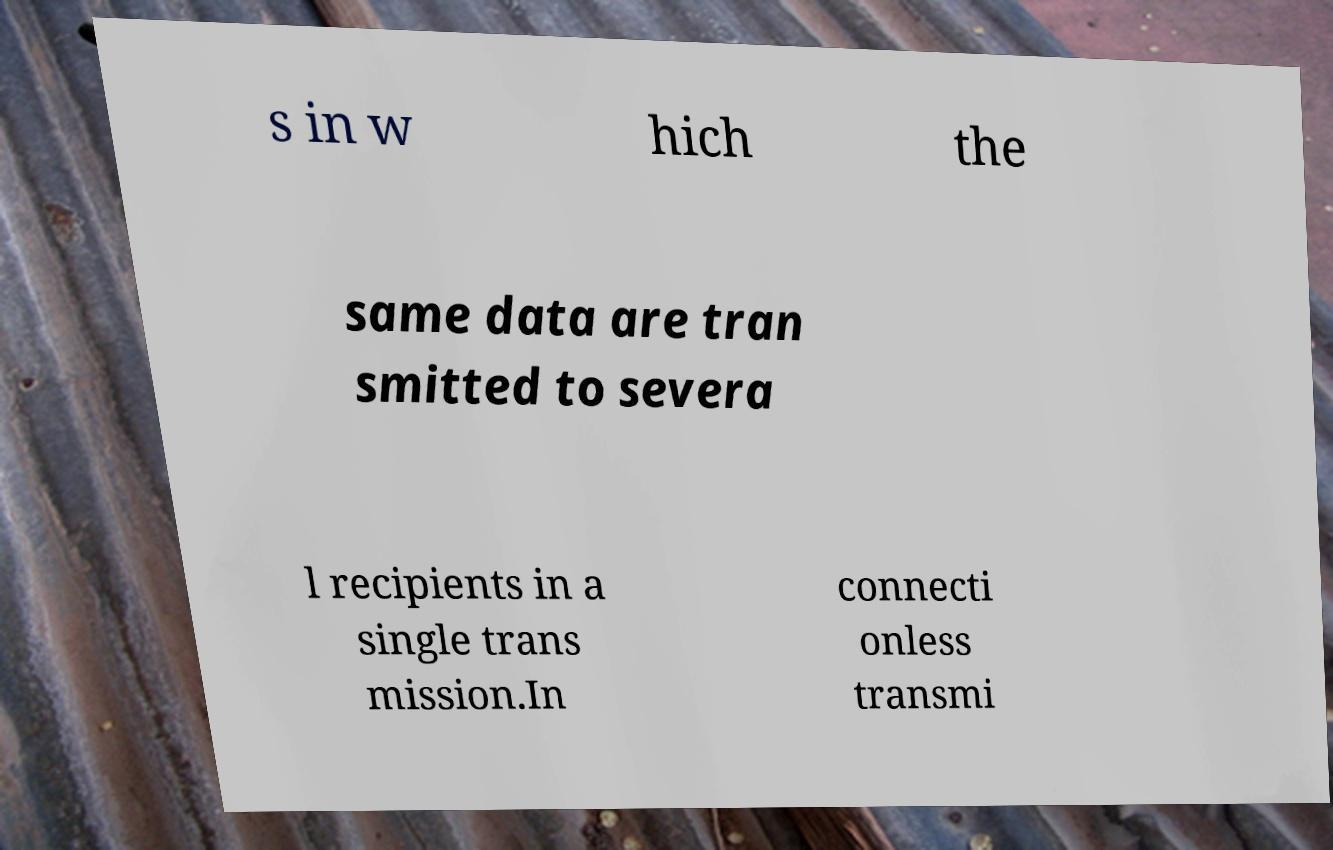For documentation purposes, I need the text within this image transcribed. Could you provide that? s in w hich the same data are tran smitted to severa l recipients in a single trans mission.In connecti onless transmi 